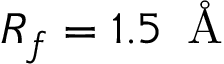<formula> <loc_0><loc_0><loc_500><loc_500>R _ { f } = 1 . 5 \, \AA</formula> 